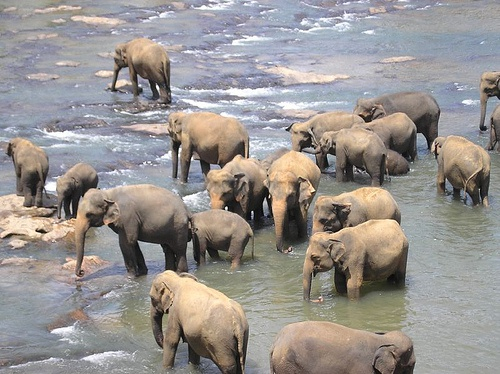Describe the objects in this image and their specific colors. I can see elephant in gray, black, darkgray, and tan tones, elephant in gray, tan, and black tones, elephant in gray, black, darkgray, and tan tones, elephant in gray, black, and tan tones, and elephant in gray, tan, and darkgray tones in this image. 